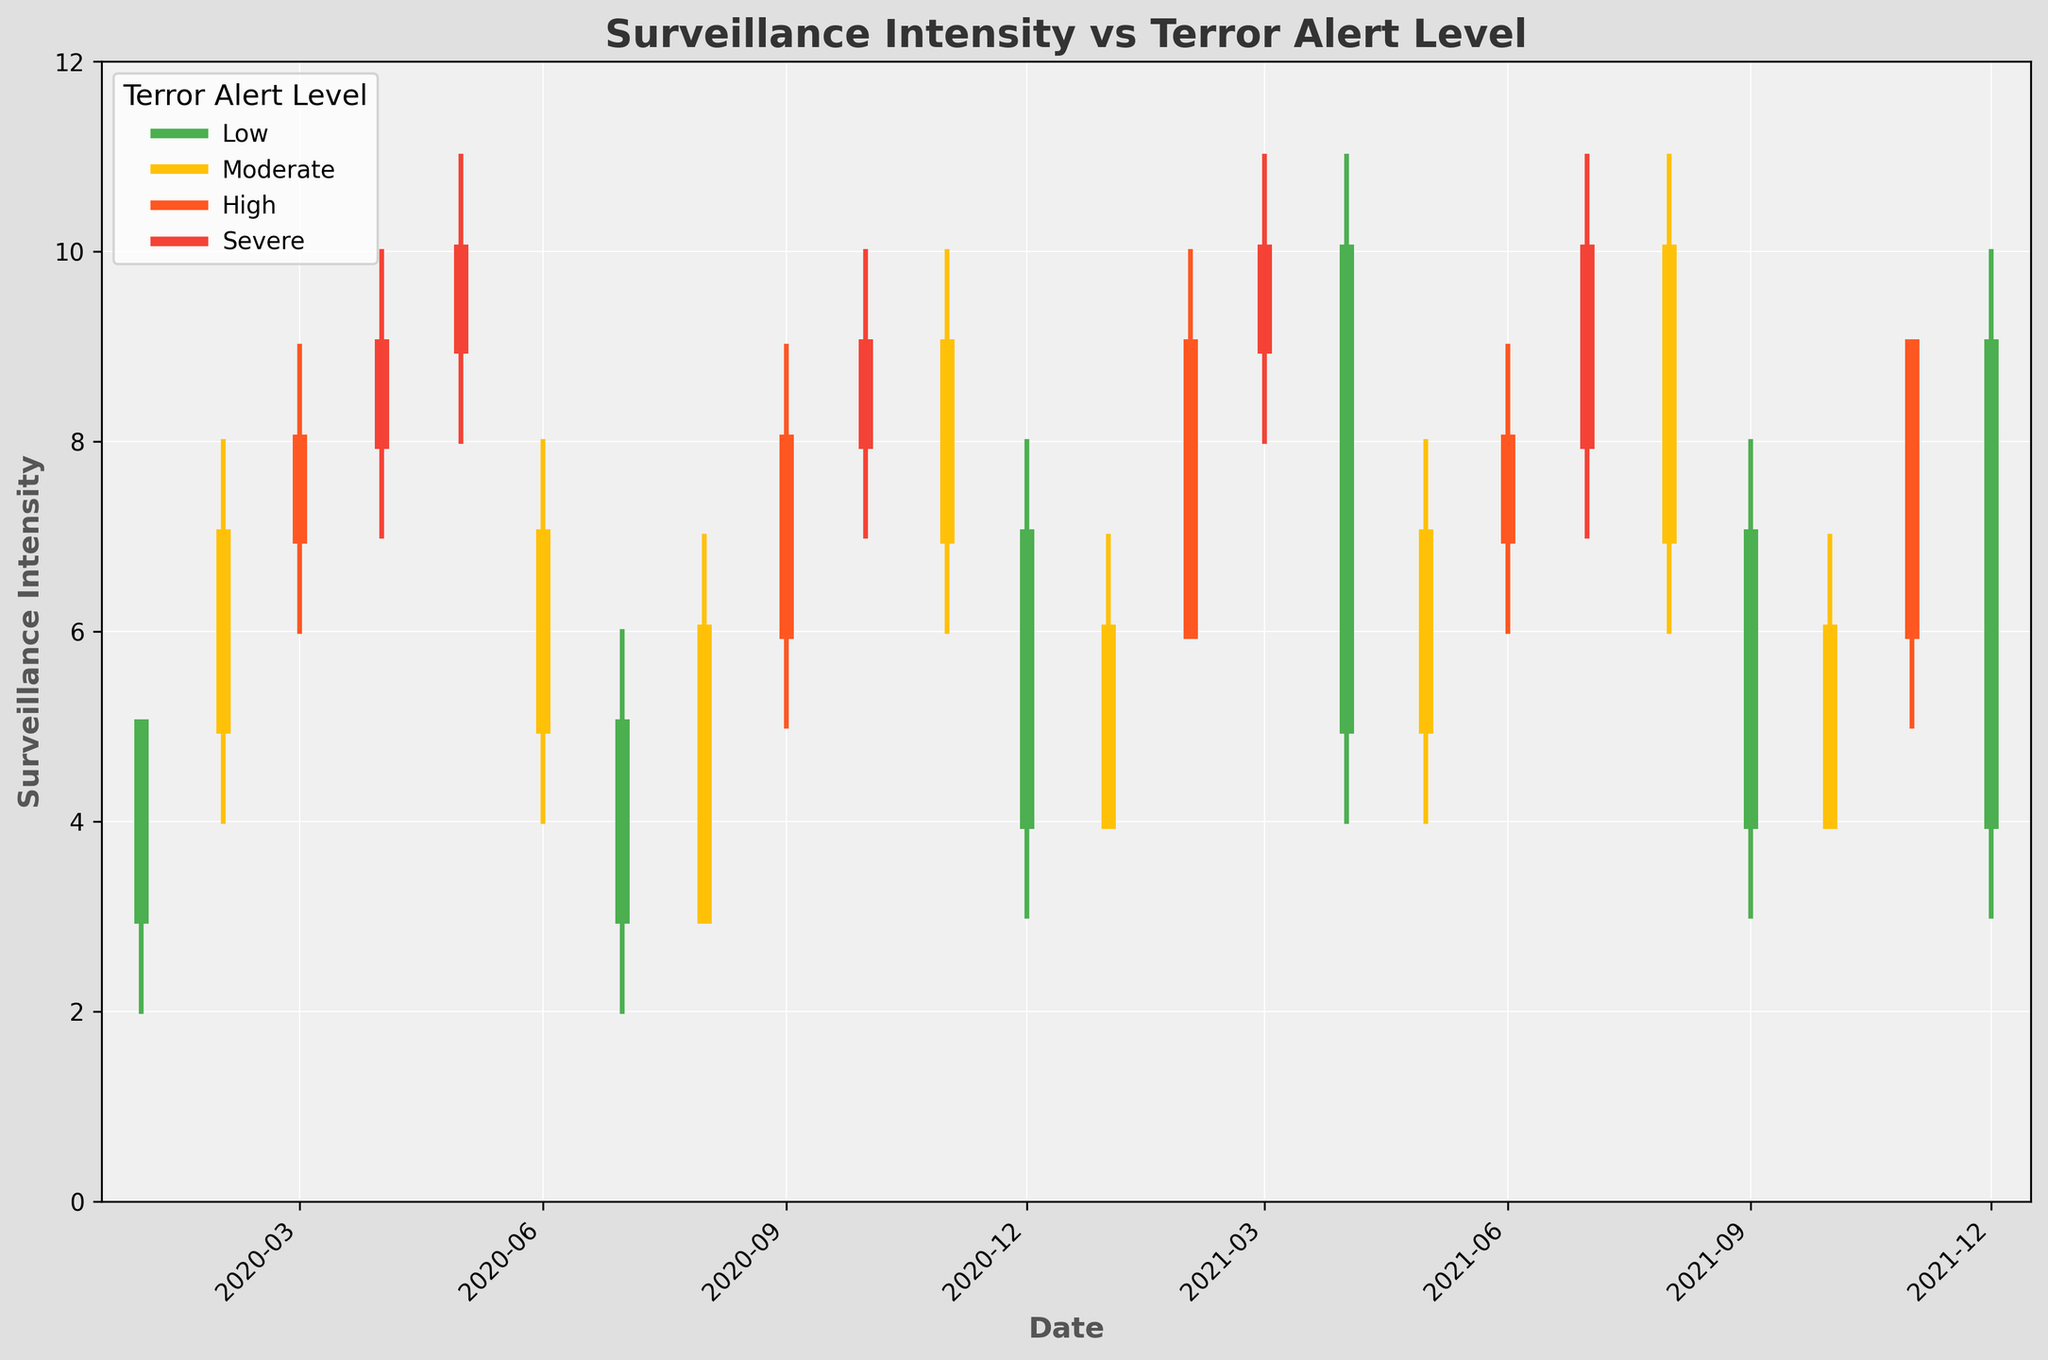When was the highest surveillance intensity recorded? By examining the candlestick plots for the highest values, the maximum surveillance intensity was at 11. This happened on multiple occasions, including April 2021 and July 2021.
Answer: April 2021 and July 2021 How many times was the terror alert level 'Severe' within the timeframe? Check the legend color for 'Severe' (red) and count the number of candlesticks that are colored red. There are five 'Severe' alerts.
Answer: 5 What is the trend in surveillance intensity when the terror alert changes from 'Moderate' to 'Low'? Look for time periods when the alert levels transition from 'Moderate' (yellow) to 'Low' (green). Observe that during these transitions (e.g., February 2020 to March 2020, December 2020 to January 2021), the closing surveillance intensity drops.
Answer: Dropping During which month did we observe the maximum decrease in surveillance intensity? To identify the maximum decrease, look for the largest difference between the open and close values where the close is lower than the open. The maximum drop happens in April 2021 where the intensity went down from 10 to 5.
Answer: April 2021 How often is the closing surveillance intensity higher than the opening intensity? For each month, compare the close and open values. A higher count of close values is seen in January, February, March, August, September, and October 2020, totaling seven months.
Answer: 7 months Which month had the highest 'low' value of surveillance intensity? The 'low' value reaches the maximum (8) in both April 2021 and March 2021. These observations can be seen from the bottom of the low lines touching the maximum low value.
Answer: April 2021 and March 2021 What was the surveillance intensity trend when the terror alert level was 'High'? Examine the months signified in 'High' (orange) and observe the trend. Typically, surveillance intensity either remains high or sees a gradual increment. For example, from June 2020 to October 2020, it stays robustly upwards or remains stable.
Answer: Consistently high or increasing Which month witnessed the smallest gap between the open and close surveillance intensity values? Identify the month with the smallest gap. This occurs in March 2021 and March 2020 where the open and close values were same (both were 10 and 8 respectively).
Answer: March 2021 and March 2020 What observation can be made about the surveillance intensity right after a 'Severe' alert level? By observing the candlestick for the months following the red-colored (Severe) periods (April, May 2020, February, March 2021), it tends to decrease, indicating relaxation.
Answer: Tends to decrease 